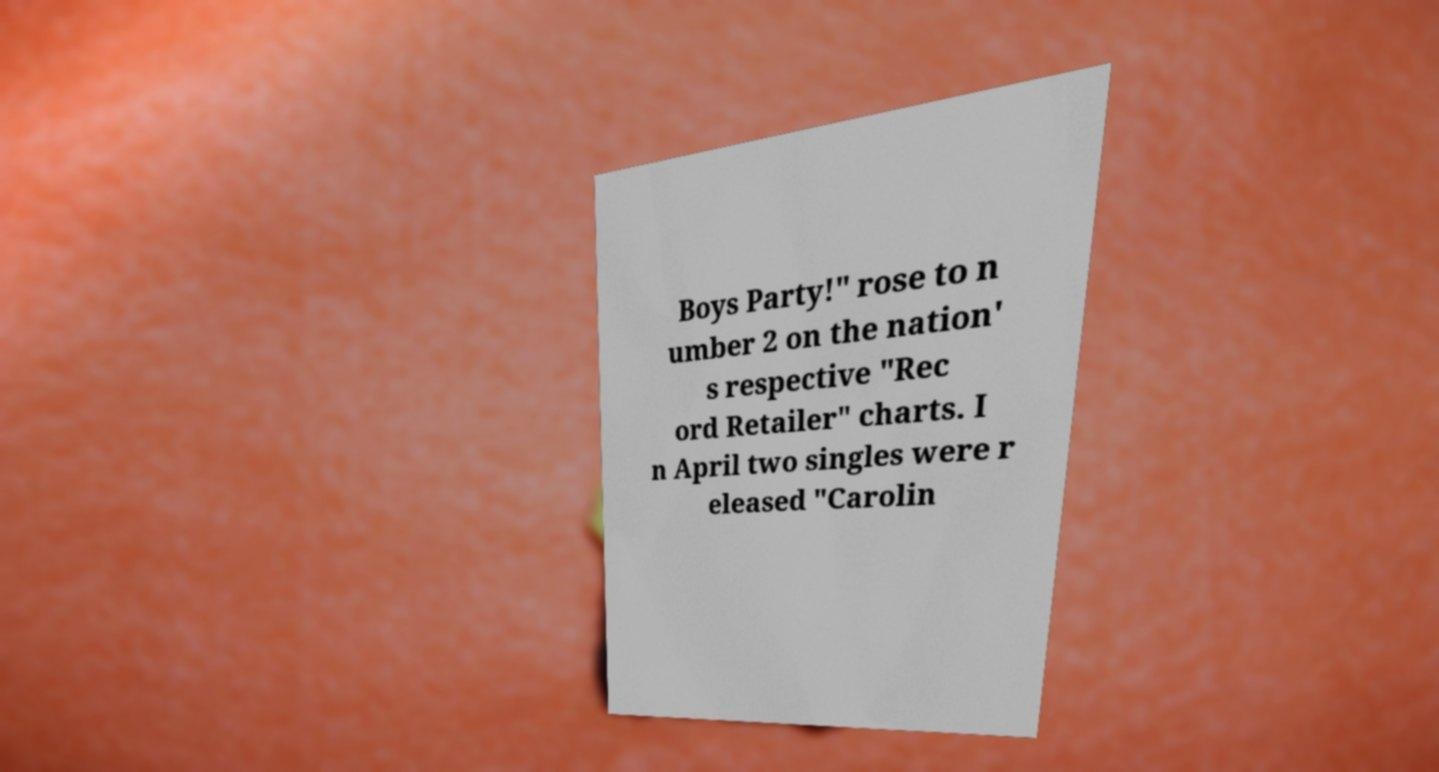Could you extract and type out the text from this image? Boys Party!" rose to n umber 2 on the nation' s respective "Rec ord Retailer" charts. I n April two singles were r eleased "Carolin 